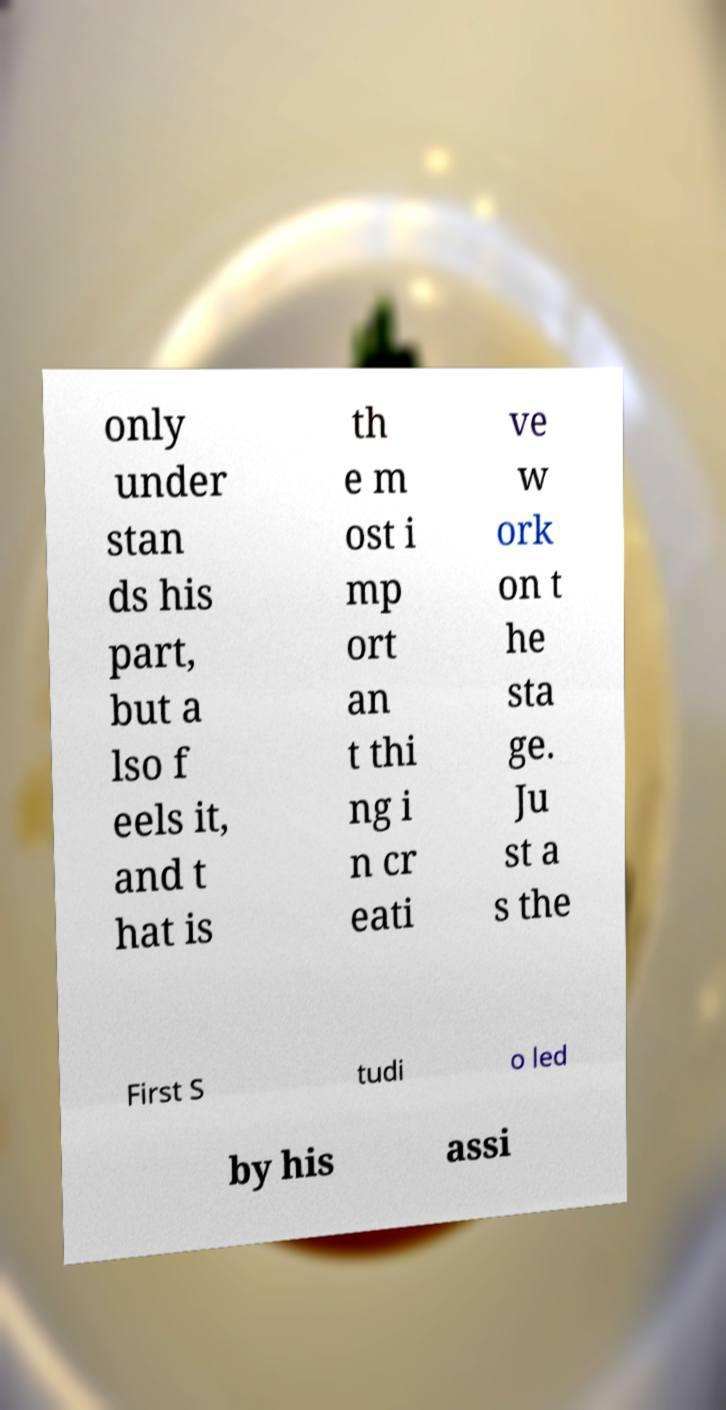For documentation purposes, I need the text within this image transcribed. Could you provide that? only under stan ds his part, but a lso f eels it, and t hat is th e m ost i mp ort an t thi ng i n cr eati ve w ork on t he sta ge. Ju st a s the First S tudi o led by his assi 